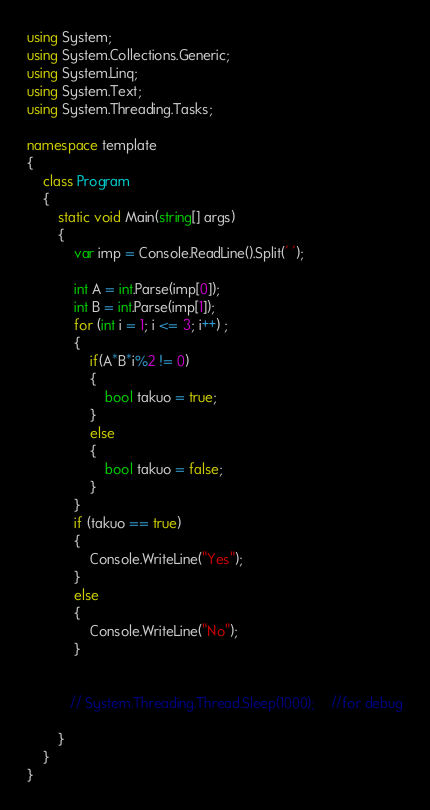<code> <loc_0><loc_0><loc_500><loc_500><_C#_>using System;
using System.Collections.Generic;
using System.Linq;
using System.Text;
using System.Threading.Tasks;

namespace template
{
    class Program
    {
        static void Main(string[] args)
        {
            var imp = Console.ReadLine().Split(' ');

            int A = int.Parse(imp[0]);
            int B = int.Parse(imp[1]);
            for (int i = 1; i <= 3; i++) ;
            {
                if(A*B*i%2 != 0)
                {
                    bool takuo = true;
                }
                else
                {
                    bool takuo = false;
                }
            }
            if (takuo == true)
            {
                Console.WriteLine("Yes");
            }
            else
            {
                Console.WriteLine("No");
            }


           // System.Threading.Thread.Sleep(1000);    //for debug

        }
    }
}</code> 